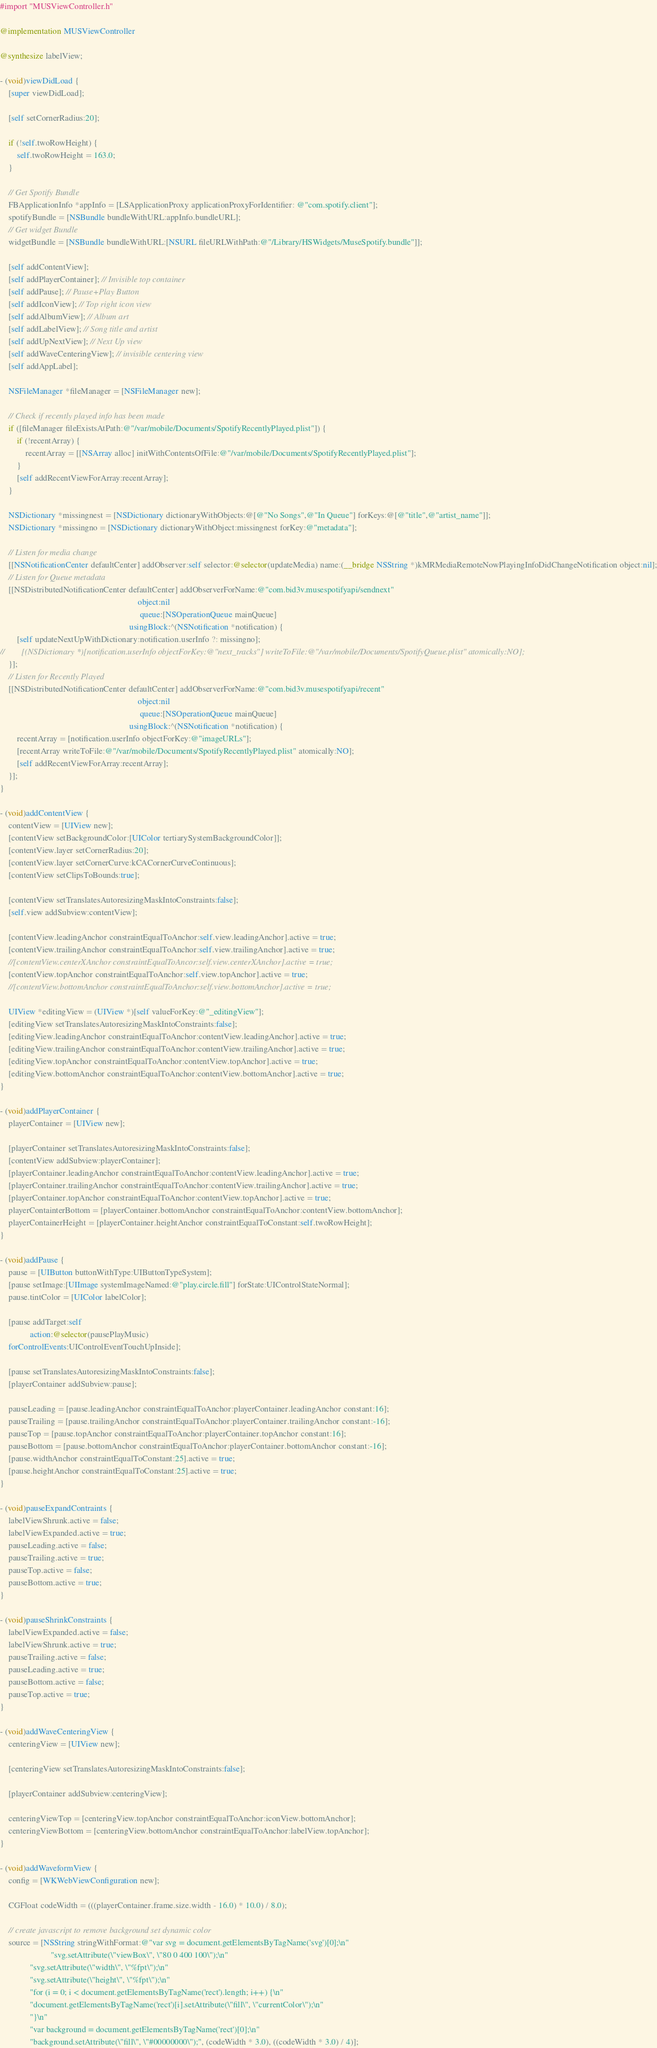Convert code to text. <code><loc_0><loc_0><loc_500><loc_500><_ObjectiveC_>#import "MUSViewController.h"

@implementation MUSViewController

@synthesize labelView;

- (void)viewDidLoad {
	[super viewDidLoad];
    
    [self setCornerRadius:20];
    
    if (!self.twoRowHeight) {
        self.twoRowHeight = 163.0;
    }
    
    // Get Spotify Bundle
    FBApplicationInfo *appInfo = [LSApplicationProxy applicationProxyForIdentifier: @"com.spotify.client"];
    spotifyBundle = [NSBundle bundleWithURL:appInfo.bundleURL];
    // Get widget Bundle
    widgetBundle = [NSBundle bundleWithURL:[NSURL fileURLWithPath:@"/Library/HSWidgets/MuseSpotify.bundle"]];

    [self addContentView];
    [self addPlayerContainer]; // Invisible top container
    [self addPause]; // Pause+Play Button
    [self addIconView]; // Top right icon view
    [self addAlbumView]; // Album art
    [self addLabelView]; // Song title and artist
    [self addUpNextView]; // Next Up view
    [self addWaveCenteringView]; // invisible centering view
    [self addAppLabel];
    
    NSFileManager *fileManager = [NSFileManager new];
    
    // Check if recently played info has been made
    if ([fileManager fileExistsAtPath:@"/var/mobile/Documents/SpotifyRecentlyPlayed.plist"]) {
        if (!recentArray) {
            recentArray = [[NSArray alloc] initWithContentsOfFile:@"/var/mobile/Documents/SpotifyRecentlyPlayed.plist"];
        }
        [self addRecentViewForArray:recentArray];
    }
    
    NSDictionary *missingnest = [NSDictionary dictionaryWithObjects:@[@"No Songs",@"In Queue"] forKeys:@[@"title",@"artist_name"]];
    NSDictionary *missingno = [NSDictionary dictionaryWithObject:missingnest forKey:@"metadata"];
    
    // Listen for media change
    [[NSNotificationCenter defaultCenter] addObserver:self selector:@selector(updateMedia) name:(__bridge NSString *)kMRMediaRemoteNowPlayingInfoDidChangeNotification object:nil];
    // Listen for Queue metadata
    [[NSDistributedNotificationCenter defaultCenter] addObserverForName:@"com.bid3v.musespotifyapi/sendnext"
                                                                 object:nil
                                                                  queue:[NSOperationQueue mainQueue]
                                                             usingBlock:^(NSNotification *notification) {
        [self updateNextUpWithDictionary:notification.userInfo ?: missingno];
//        [(NSDictionary *)[notification.userInfo objectForKey:@"next_tracks"] writeToFile:@"/var/mobile/Documents/SpotifyQueue.plist" atomically:NO];
    }];
    // Listen for Recently Played
    [[NSDistributedNotificationCenter defaultCenter] addObserverForName:@"com.bid3v.musespotifyapi/recent"
                                                                 object:nil
                                                                  queue:[NSOperationQueue mainQueue]
                                                             usingBlock:^(NSNotification *notification) {
        recentArray = [notification.userInfo objectForKey:@"imageURLs"];
        [recentArray writeToFile:@"/var/mobile/Documents/SpotifyRecentlyPlayed.plist" atomically:NO];
        [self addRecentViewForArray:recentArray];
    }];
}

- (void)addContentView {
    contentView = [UIView new];
    [contentView setBackgroundColor:[UIColor tertiarySystemBackgroundColor]];
    [contentView.layer setCornerRadius:20];
    [contentView.layer setCornerCurve:kCACornerCurveContinuous];
    [contentView setClipsToBounds:true];
    
    [contentView setTranslatesAutoresizingMaskIntoConstraints:false];
    [self.view addSubview:contentView];
    
    [contentView.leadingAnchor constraintEqualToAnchor:self.view.leadingAnchor].active = true;
    [contentView.trailingAnchor constraintEqualToAnchor:self.view.trailingAnchor].active = true;
    //[contentView.centerXAnchor constraintEqualToAncor:self.view.centerXAnchor].active = true;
    [contentView.topAnchor constraintEqualToAnchor:self.view.topAnchor].active = true;
    //[contentView.bottomAnchor constraintEqualToAnchor:self.view.bottomAnchor].active = true;
    
    UIView *editingView = (UIView *)[self valueForKey:@"_editingView"];
    [editingView setTranslatesAutoresizingMaskIntoConstraints:false];
    [editingView.leadingAnchor constraintEqualToAnchor:contentView.leadingAnchor].active = true;
    [editingView.trailingAnchor constraintEqualToAnchor:contentView.trailingAnchor].active = true;
    [editingView.topAnchor constraintEqualToAnchor:contentView.topAnchor].active = true;
    [editingView.bottomAnchor constraintEqualToAnchor:contentView.bottomAnchor].active = true;
}

- (void)addPlayerContainer {
    playerContainer = [UIView new];
    
    [playerContainer setTranslatesAutoresizingMaskIntoConstraints:false];
    [contentView addSubview:playerContainer];
    [playerContainer.leadingAnchor constraintEqualToAnchor:contentView.leadingAnchor].active = true;
    [playerContainer.trailingAnchor constraintEqualToAnchor:contentView.trailingAnchor].active = true;
    [playerContainer.topAnchor constraintEqualToAnchor:contentView.topAnchor].active = true;
    playerContainterBottom = [playerContainer.bottomAnchor constraintEqualToAnchor:contentView.bottomAnchor];
    playerContainerHeight = [playerContainer.heightAnchor constraintEqualToConstant:self.twoRowHeight];
}

- (void)addPause {
    pause = [UIButton buttonWithType:UIButtonTypeSystem];
    [pause setImage:[UIImage systemImageNamed:@"play.circle.fill"] forState:UIControlStateNormal];
    pause.tintColor = [UIColor labelColor];
    
    [pause addTarget:self
              action:@selector(pausePlayMusic)
    forControlEvents:UIControlEventTouchUpInside];
    
    [pause setTranslatesAutoresizingMaskIntoConstraints:false];
    [playerContainer addSubview:pause];
    
    pauseLeading = [pause.leadingAnchor constraintEqualToAnchor:playerContainer.leadingAnchor constant:16];
    pauseTrailing = [pause.trailingAnchor constraintEqualToAnchor:playerContainer.trailingAnchor constant:-16];
    pauseTop = [pause.topAnchor constraintEqualToAnchor:playerContainer.topAnchor constant:16];
    pauseBottom = [pause.bottomAnchor constraintEqualToAnchor:playerContainer.bottomAnchor constant:-16];
    [pause.widthAnchor constraintEqualToConstant:25].active = true;
    [pause.heightAnchor constraintEqualToConstant:25].active = true;
}

- (void)pauseExpandContraints {
    labelViewShrunk.active = false;
    labelViewExpanded.active = true;
    pauseLeading.active = false;
    pauseTrailing.active = true;
    pauseTop.active = false;
    pauseBottom.active = true;
}

- (void)pauseShrinkConstraints {
    labelViewExpanded.active = false;
    labelViewShrunk.active = true;
    pauseTrailing.active = false;
    pauseLeading.active = true;
    pauseBottom.active = false;
    pauseTop.active = true;
}

- (void)addWaveCenteringView {
    centeringView = [UIView new];

    [centeringView setTranslatesAutoresizingMaskIntoConstraints:false];

    [playerContainer addSubview:centeringView];

    centeringViewTop = [centeringView.topAnchor constraintEqualToAnchor:iconView.bottomAnchor];
    centeringViewBottom = [centeringView.bottomAnchor constraintEqualToAnchor:labelView.topAnchor];
}

- (void)addWaveformView {
    config = [WKWebViewConfiguration new];
    
    CGFloat codeWidth = (((playerContainer.frame.size.width - 16.0) * 10.0) / 8.0);
    
    // create javascript to remove background set dynamic color
    source = [NSString stringWithFormat:@"var svg = document.getElementsByTagName('svg')[0];\n"
                        "svg.setAttribute(\"viewBox\", \"80 0 400 100\");\n"
              "svg.setAttribute(\"width\", \"%fpt\");\n"
              "svg.setAttribute(\"height\", \"%fpt\");\n"
              "for (i = 0; i < document.getElementsByTagName('rect').length; i++) {\n"
              "document.getElementsByTagName('rect')[i].setAttribute(\"fill\", \"currentColor\");\n"
              "}\n"
              "var background = document.getElementsByTagName('rect')[0];\n"
              "background.setAttribute(\"fill\", \"#00000000\");", (codeWidth * 3.0), ((codeWidth * 3.0) / 4)];</code> 